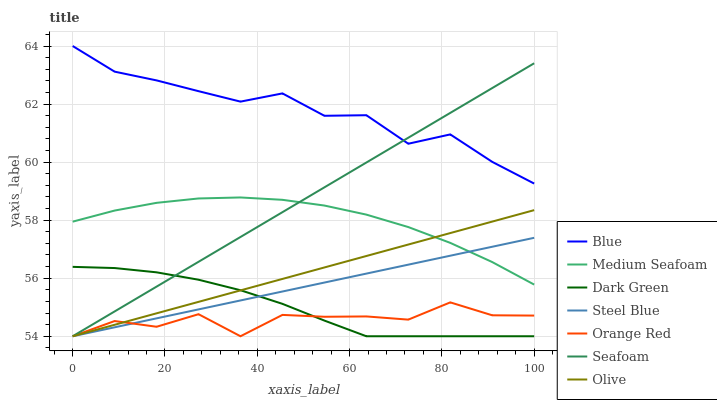Does Steel Blue have the minimum area under the curve?
Answer yes or no. No. Does Steel Blue have the maximum area under the curve?
Answer yes or no. No. Is Orange Red the smoothest?
Answer yes or no. No. Is Steel Blue the roughest?
Answer yes or no. No. Does Medium Seafoam have the lowest value?
Answer yes or no. No. Does Steel Blue have the highest value?
Answer yes or no. No. Is Orange Red less than Medium Seafoam?
Answer yes or no. Yes. Is Blue greater than Steel Blue?
Answer yes or no. Yes. Does Orange Red intersect Medium Seafoam?
Answer yes or no. No. 